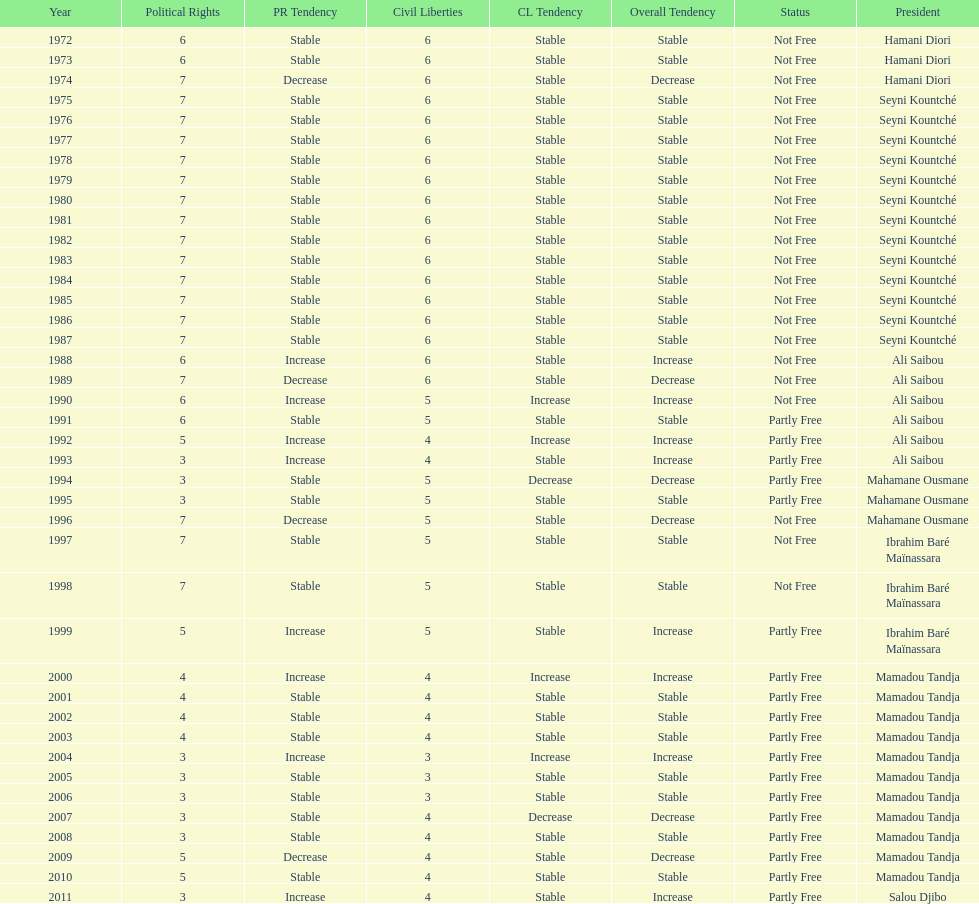What is the number of time seyni kountche has been president? 13. 